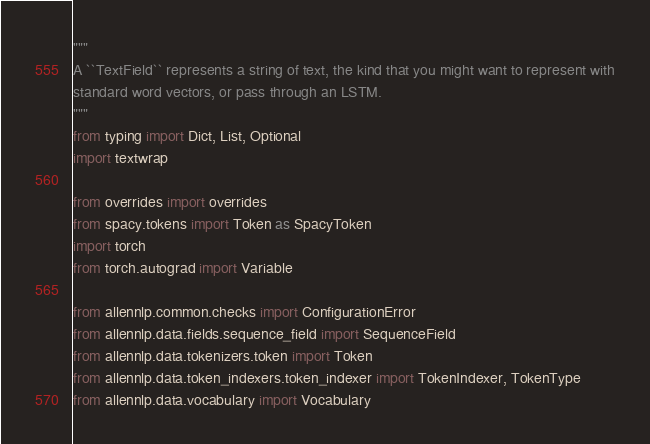Convert code to text. <code><loc_0><loc_0><loc_500><loc_500><_Python_>"""
A ``TextField`` represents a string of text, the kind that you might want to represent with
standard word vectors, or pass through an LSTM.
"""
from typing import Dict, List, Optional
import textwrap

from overrides import overrides
from spacy.tokens import Token as SpacyToken
import torch
from torch.autograd import Variable

from allennlp.common.checks import ConfigurationError
from allennlp.data.fields.sequence_field import SequenceField
from allennlp.data.tokenizers.token import Token
from allennlp.data.token_indexers.token_indexer import TokenIndexer, TokenType
from allennlp.data.vocabulary import Vocabulary</code> 